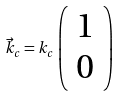<formula> <loc_0><loc_0><loc_500><loc_500>\vec { k } _ { c } = k _ { c } \left ( \begin{array} { c } 1 \\ 0 \end{array} \right )</formula> 